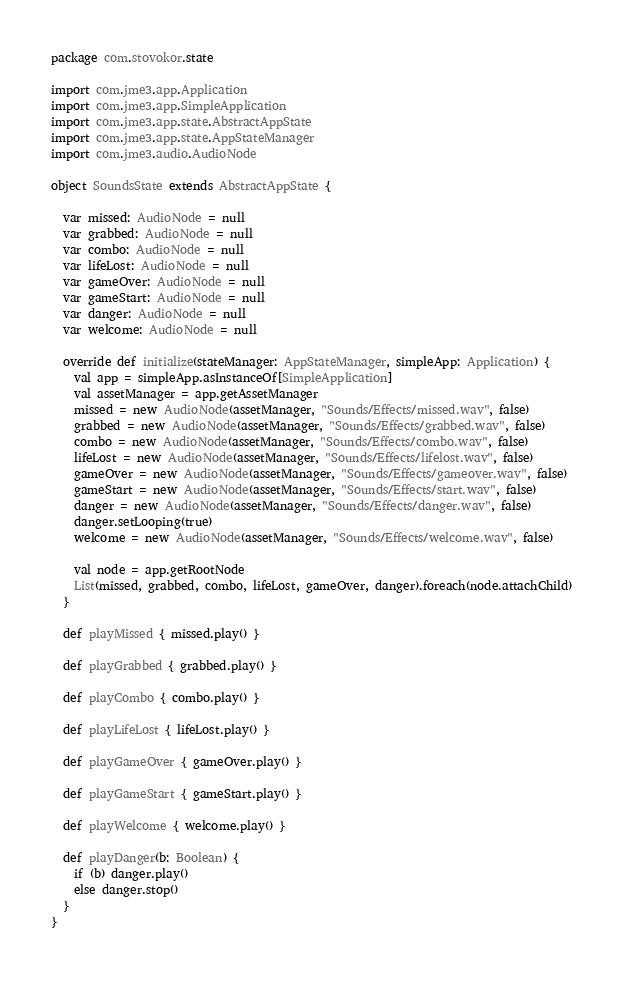Convert code to text. <code><loc_0><loc_0><loc_500><loc_500><_Scala_>package com.stovokor.state

import com.jme3.app.Application
import com.jme3.app.SimpleApplication
import com.jme3.app.state.AbstractAppState
import com.jme3.app.state.AppStateManager
import com.jme3.audio.AudioNode

object SoundsState extends AbstractAppState {

  var missed: AudioNode = null
  var grabbed: AudioNode = null
  var combo: AudioNode = null
  var lifeLost: AudioNode = null
  var gameOver: AudioNode = null
  var gameStart: AudioNode = null
  var danger: AudioNode = null
  var welcome: AudioNode = null

  override def initialize(stateManager: AppStateManager, simpleApp: Application) {
    val app = simpleApp.asInstanceOf[SimpleApplication]
    val assetManager = app.getAssetManager
    missed = new AudioNode(assetManager, "Sounds/Effects/missed.wav", false)
    grabbed = new AudioNode(assetManager, "Sounds/Effects/grabbed.wav", false)
    combo = new AudioNode(assetManager, "Sounds/Effects/combo.wav", false)
    lifeLost = new AudioNode(assetManager, "Sounds/Effects/lifelost.wav", false)
    gameOver = new AudioNode(assetManager, "Sounds/Effects/gameover.wav", false)
    gameStart = new AudioNode(assetManager, "Sounds/Effects/start.wav", false)
    danger = new AudioNode(assetManager, "Sounds/Effects/danger.wav", false)
    danger.setLooping(true)
    welcome = new AudioNode(assetManager, "Sounds/Effects/welcome.wav", false)

    val node = app.getRootNode
    List(missed, grabbed, combo, lifeLost, gameOver, danger).foreach(node.attachChild)
  }

  def playMissed { missed.play() }

  def playGrabbed { grabbed.play() }

  def playCombo { combo.play() }

  def playLifeLost { lifeLost.play() }

  def playGameOver { gameOver.play() }

  def playGameStart { gameStart.play() }

  def playWelcome { welcome.play() }

  def playDanger(b: Boolean) {
    if (b) danger.play()
    else danger.stop()
  }
}</code> 